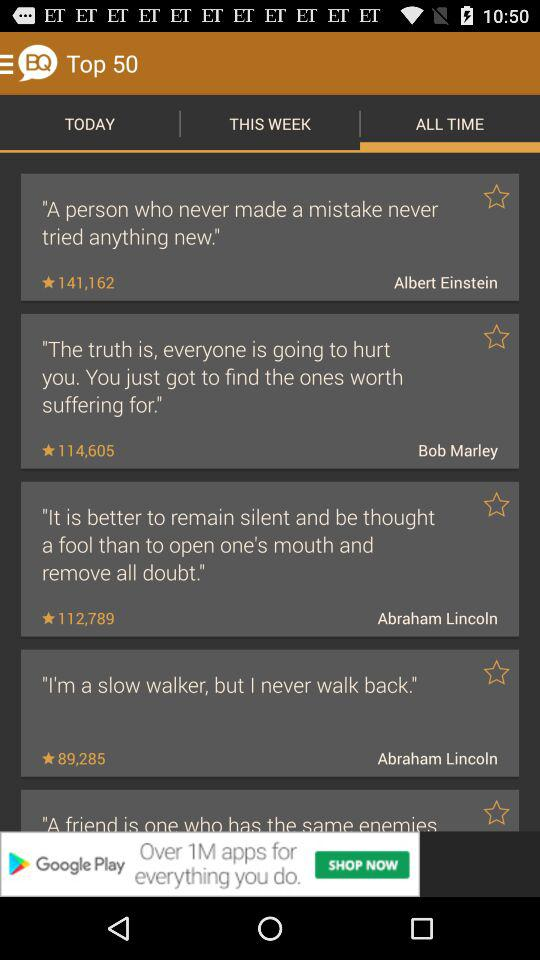What tab is currently selected? The selected tab is "ALL TIME". 